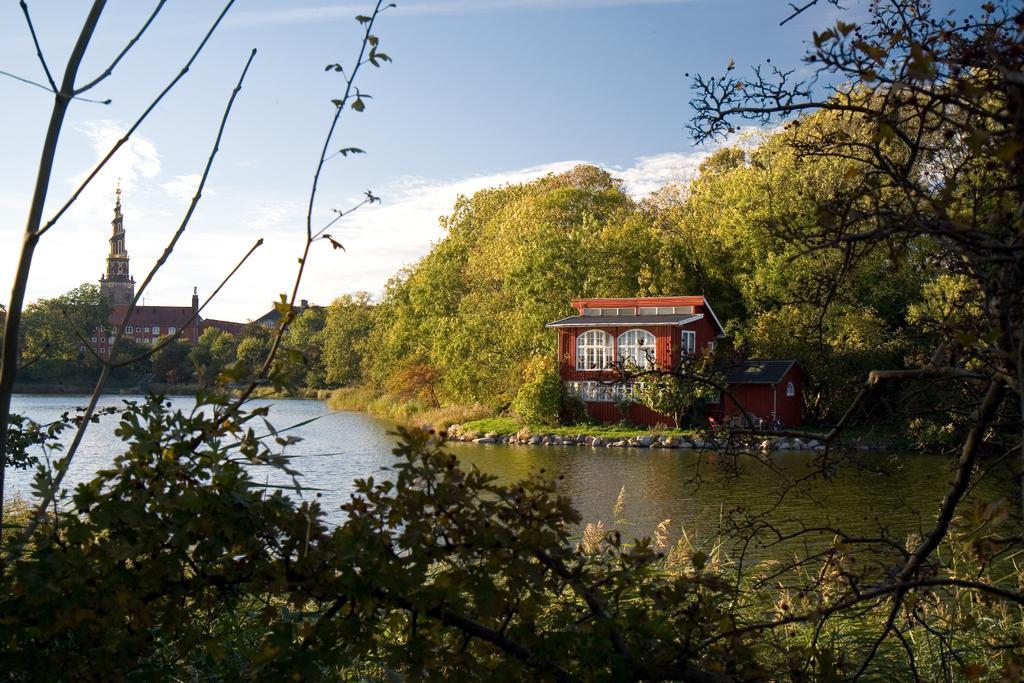Describe this image in one or two sentences. In this image we can see the buildings and also many trees. We can also see the water, stones and also the sky with some clouds. 